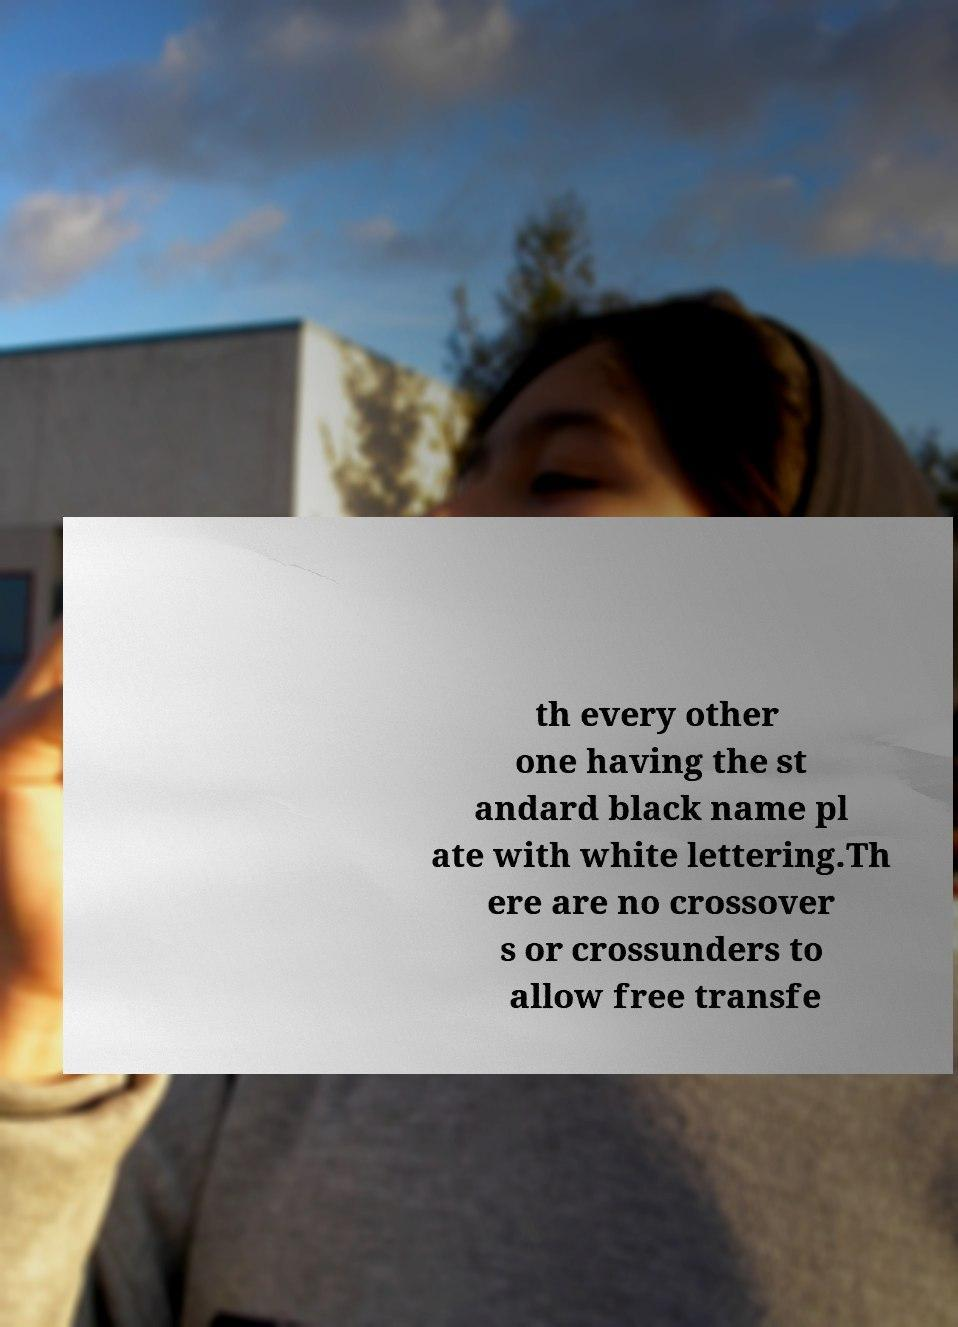Can you read and provide the text displayed in the image?This photo seems to have some interesting text. Can you extract and type it out for me? th every other one having the st andard black name pl ate with white lettering.Th ere are no crossover s or crossunders to allow free transfe 